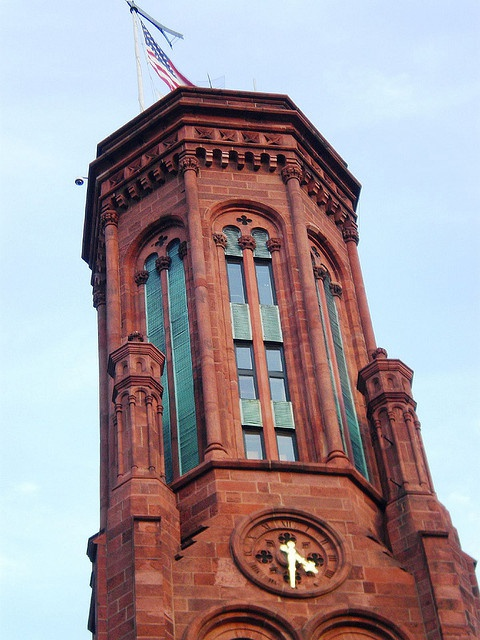Describe the objects in this image and their specific colors. I can see a clock in lightblue, brown, maroon, and black tones in this image. 